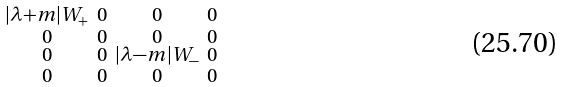Convert formula to latex. <formula><loc_0><loc_0><loc_500><loc_500>\begin{smallmatrix} | \lambda + m | W _ { + } & 0 & 0 & 0 \\ 0 & 0 & 0 & 0 \\ 0 & 0 & | \lambda - m | W _ { - } & 0 \\ 0 & 0 & 0 & 0 \end{smallmatrix}</formula> 